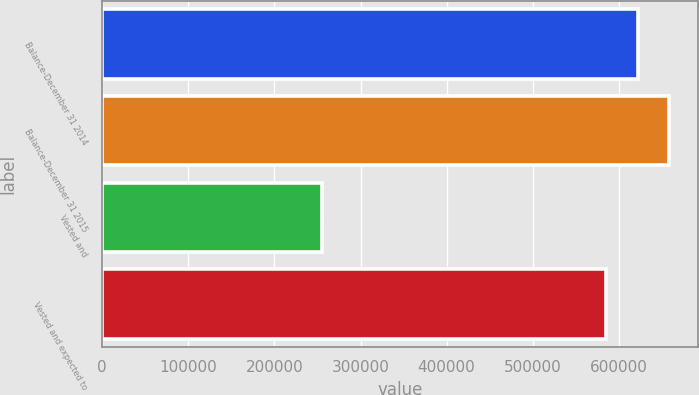Convert chart to OTSL. <chart><loc_0><loc_0><loc_500><loc_500><bar_chart><fcel>Balance-December 31 2014<fcel>Balance-December 31 2015<fcel>Vested and<fcel>Vested and expected to<nl><fcel>622268<fcel>658809<fcel>255392<fcel>585727<nl></chart> 